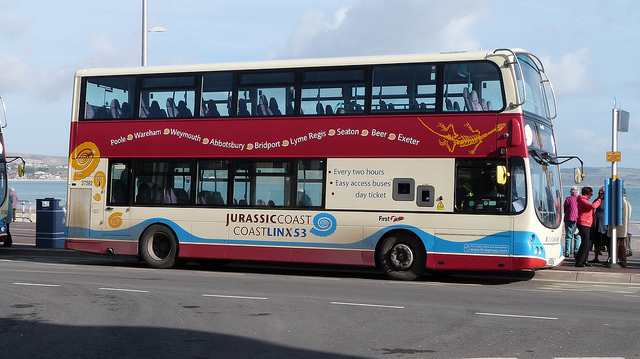Identify the text displayed in this image. Poole Warcham Weymouth Abbocsbury Bridport First ticket day buses access Easy hours two Every COASTLINX53 JURASSICCOAST Exeter Beer Seaton Lyme 